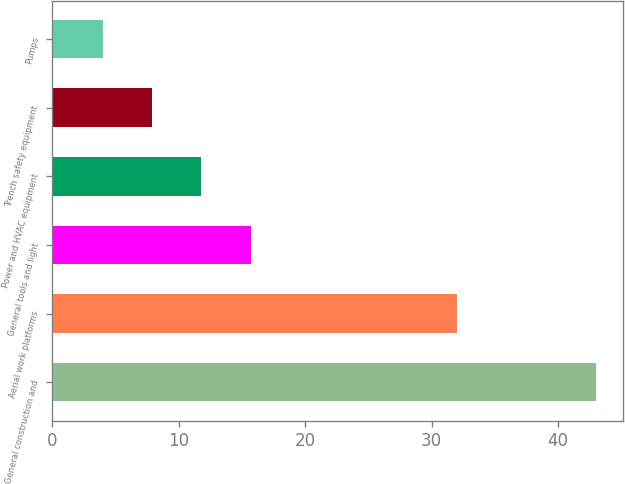Convert chart to OTSL. <chart><loc_0><loc_0><loc_500><loc_500><bar_chart><fcel>General construction and<fcel>Aerial work platforms<fcel>General tools and light<fcel>Power and HVAC equipment<fcel>Trench safety equipment<fcel>Pumps<nl><fcel>43<fcel>32<fcel>15.7<fcel>11.8<fcel>7.9<fcel>4<nl></chart> 